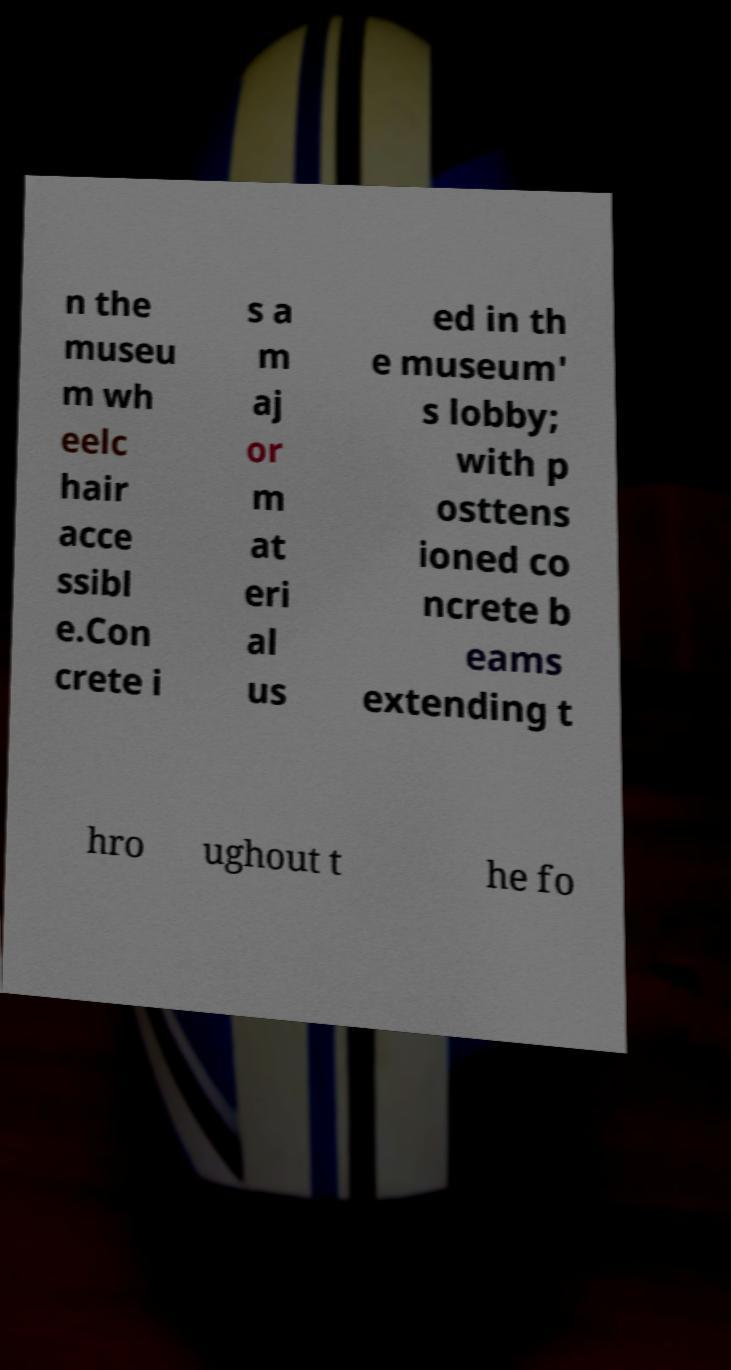Could you extract and type out the text from this image? n the museu m wh eelc hair acce ssibl e.Con crete i s a m aj or m at eri al us ed in th e museum' s lobby; with p osttens ioned co ncrete b eams extending t hro ughout t he fo 